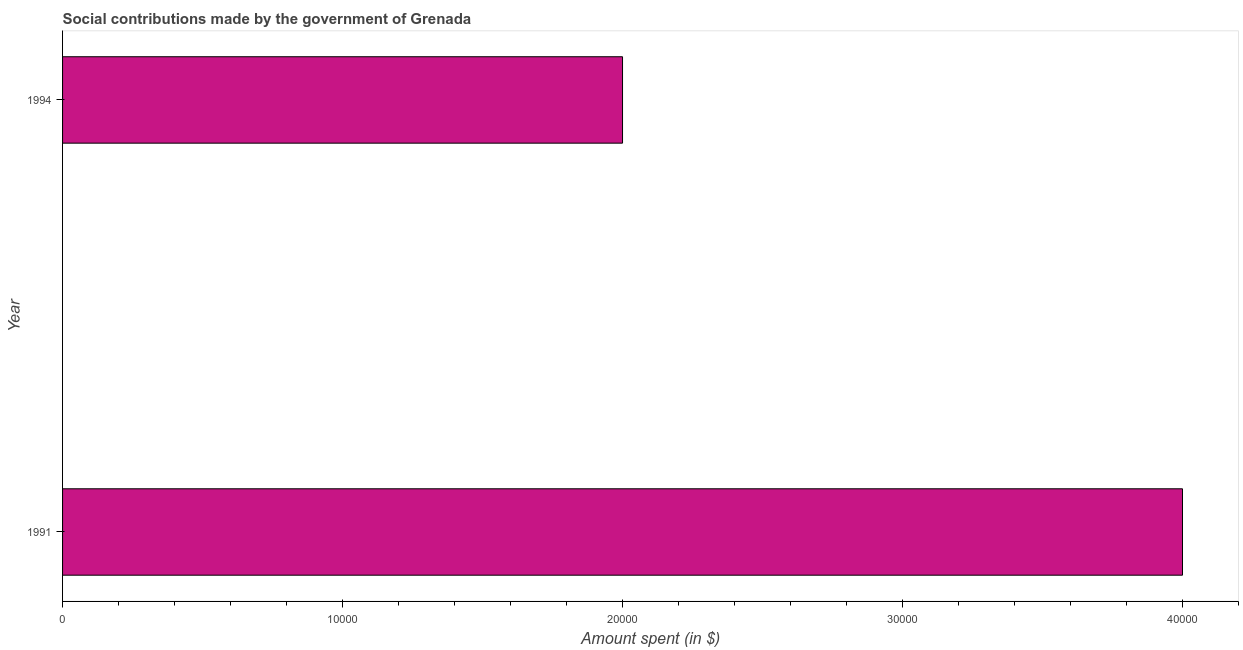Does the graph contain any zero values?
Your answer should be very brief. No. What is the title of the graph?
Your answer should be compact. Social contributions made by the government of Grenada. What is the label or title of the X-axis?
Ensure brevity in your answer.  Amount spent (in $). What is the label or title of the Y-axis?
Your answer should be compact. Year. What is the amount spent in making social contributions in 1994?
Your answer should be very brief. 2.00e+04. Across all years, what is the maximum amount spent in making social contributions?
Provide a short and direct response. 4.00e+04. Across all years, what is the minimum amount spent in making social contributions?
Provide a succinct answer. 2.00e+04. How many bars are there?
Make the answer very short. 2. What is the Amount spent (in $) in 1991?
Your answer should be compact. 4.00e+04. What is the difference between the Amount spent (in $) in 1991 and 1994?
Provide a short and direct response. 2.00e+04. 